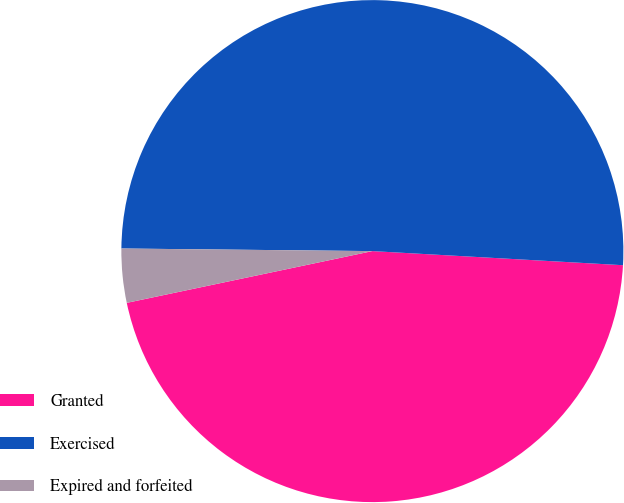Convert chart. <chart><loc_0><loc_0><loc_500><loc_500><pie_chart><fcel>Granted<fcel>Exercised<fcel>Expired and forfeited<nl><fcel>45.8%<fcel>50.73%<fcel>3.47%<nl></chart> 